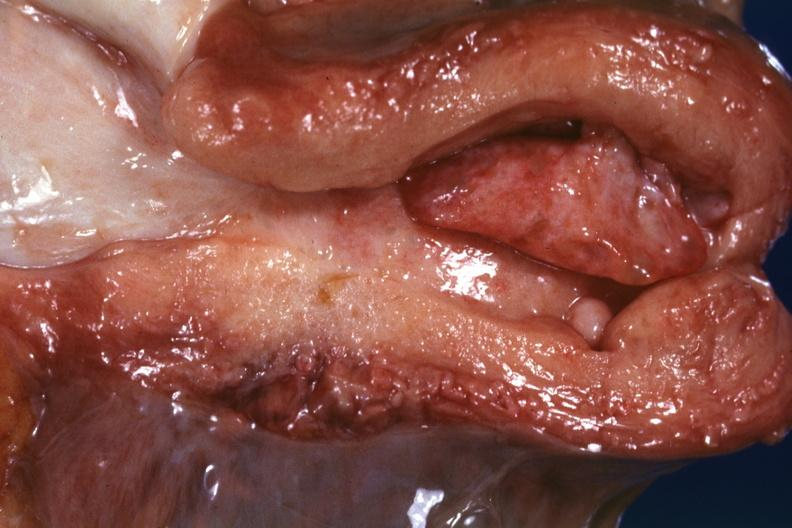s typical tuberculous exudate present?
Answer the question using a single word or phrase. No 